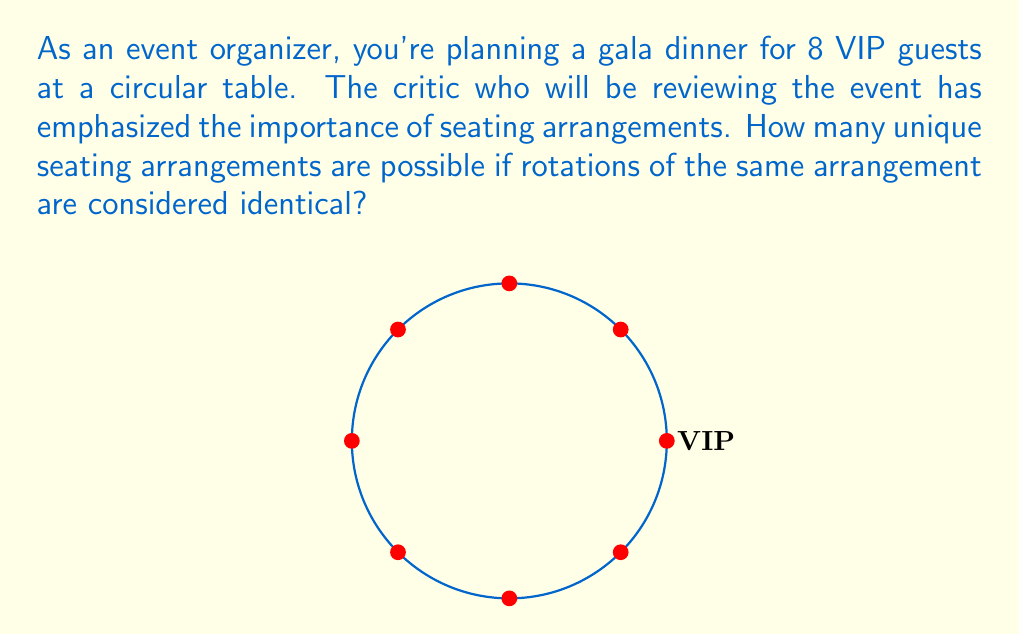Can you solve this math problem? Let's approach this step-by-step:

1) First, we need to understand that in a circular arrangement, rotations are considered the same. For example, if we have guests A, B, C in that order, it's the same as B, C, A or C, A, B.

2) In general, for n distinct objects in a circle, the number of unique arrangements is $(n-1)!$. This is because:
   - We can fix the position of one person (reducing the problem to arranging n-1 people).
   - The remaining n-1 people can be arranged in $(n-1)!$ ways.

3) In this case, we have 8 VIP guests. So, n = 8.

4) Applying the formula:
   Number of unique arrangements = $(8-1)!$ = $7!$

5) Let's calculate $7!$:
   $7! = 7 \times 6 \times 5 \times 4 \times 3 \times 2 \times 1 = 5040$

Therefore, there are 5040 unique seating arrangements for the 8 VIP guests at the circular table.
Answer: $5040$ 